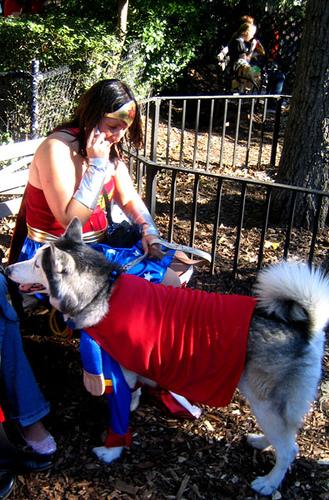How many people are there?
Be succinct. 2. What theme are the dog and owner going for?
Be succinct. Superman. What color Cape is the dog wearing?
Keep it brief. Red. 